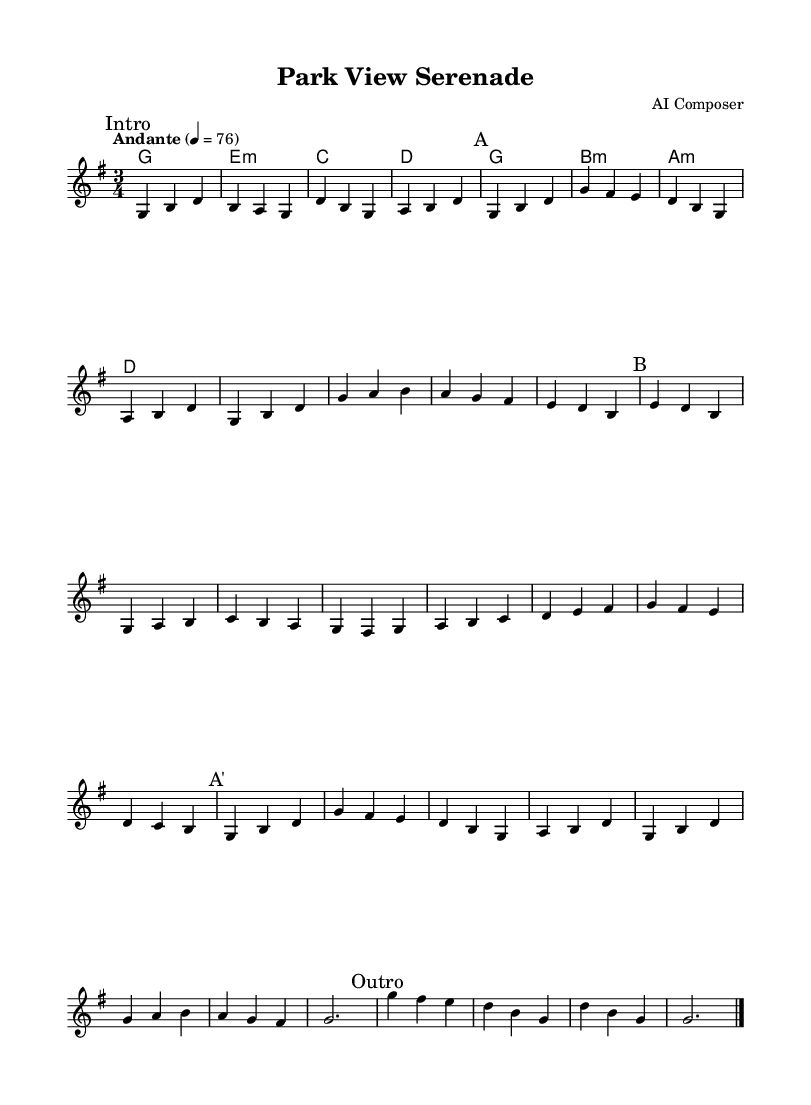What is the key signature of this music? The key signature is identified with the sharp symbols placed on the staff lines. In this piece, there is one sharp, indicating the key of G major.
Answer: G major What is the time signature of this music? The time signature is found at the beginning of the score and is indicated by two numbers. Here, the time signature is 3/4, meaning three beats per measure.
Answer: 3/4 What is the tempo marking for this piece? The tempo marking is found above the staff, specifying how fast the piece should be played. In this case, it is marked "Andante," which typically indicates a moderate pace.
Answer: Andante How many sections are there in the music? By analyzing the formal structure marked in the music, we see distinct sections labeled "Intro," "A," "B," "A'," and "Outro." Each section is clearly demarcated.
Answer: Five What is the first note of Section A? To find the first note of Section A, look at the section labeled "A" following the "Intro." The first note is written on the staff, which is G in this case.
Answer: G Which chords are played in the first line of the guitar chords? The first line of guitar chords is where each chord symbol appears. It begins with the G major chord followed by E minor, C major, and D major chords.
Answer: G, E minor, C, D What is the last measure's note at the end of the score? The last measure is listed under the "Outro" section. The last note is written on the staff, which is a whole note G, marking the end of the piece.
Answer: G 